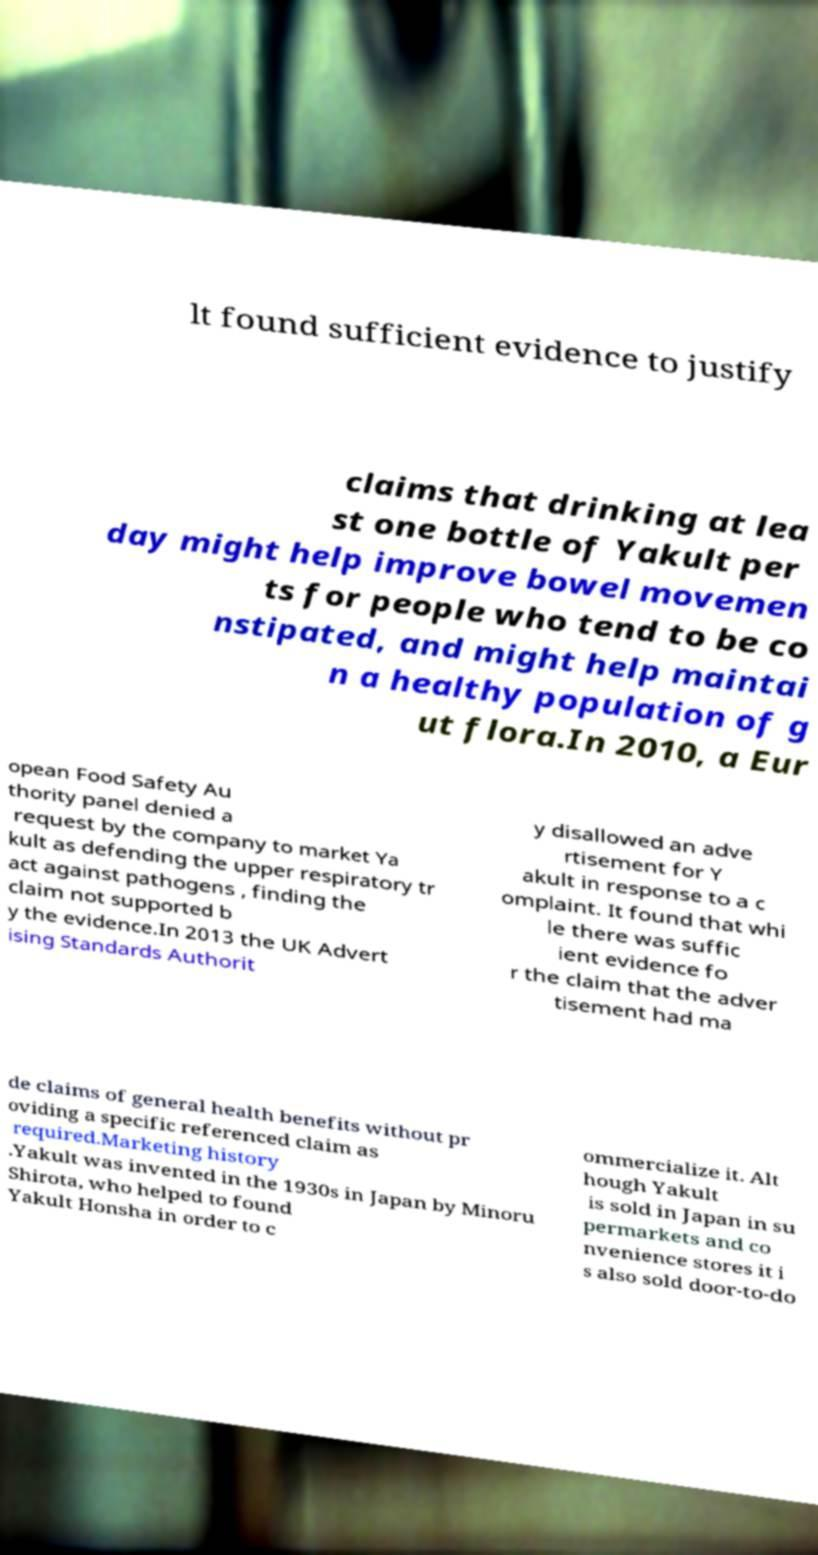Could you extract and type out the text from this image? lt found sufficient evidence to justify claims that drinking at lea st one bottle of Yakult per day might help improve bowel movemen ts for people who tend to be co nstipated, and might help maintai n a healthy population of g ut flora.In 2010, a Eur opean Food Safety Au thority panel denied a request by the company to market Ya kult as defending the upper respiratory tr act against pathogens , finding the claim not supported b y the evidence.In 2013 the UK Advert ising Standards Authorit y disallowed an adve rtisement for Y akult in response to a c omplaint. It found that whi le there was suffic ient evidence fo r the claim that the adver tisement had ma de claims of general health benefits without pr oviding a specific referenced claim as required.Marketing history .Yakult was invented in the 1930s in Japan by Minoru Shirota, who helped to found Yakult Honsha in order to c ommercialize it. Alt hough Yakult is sold in Japan in su permarkets and co nvenience stores it i s also sold door-to-do 